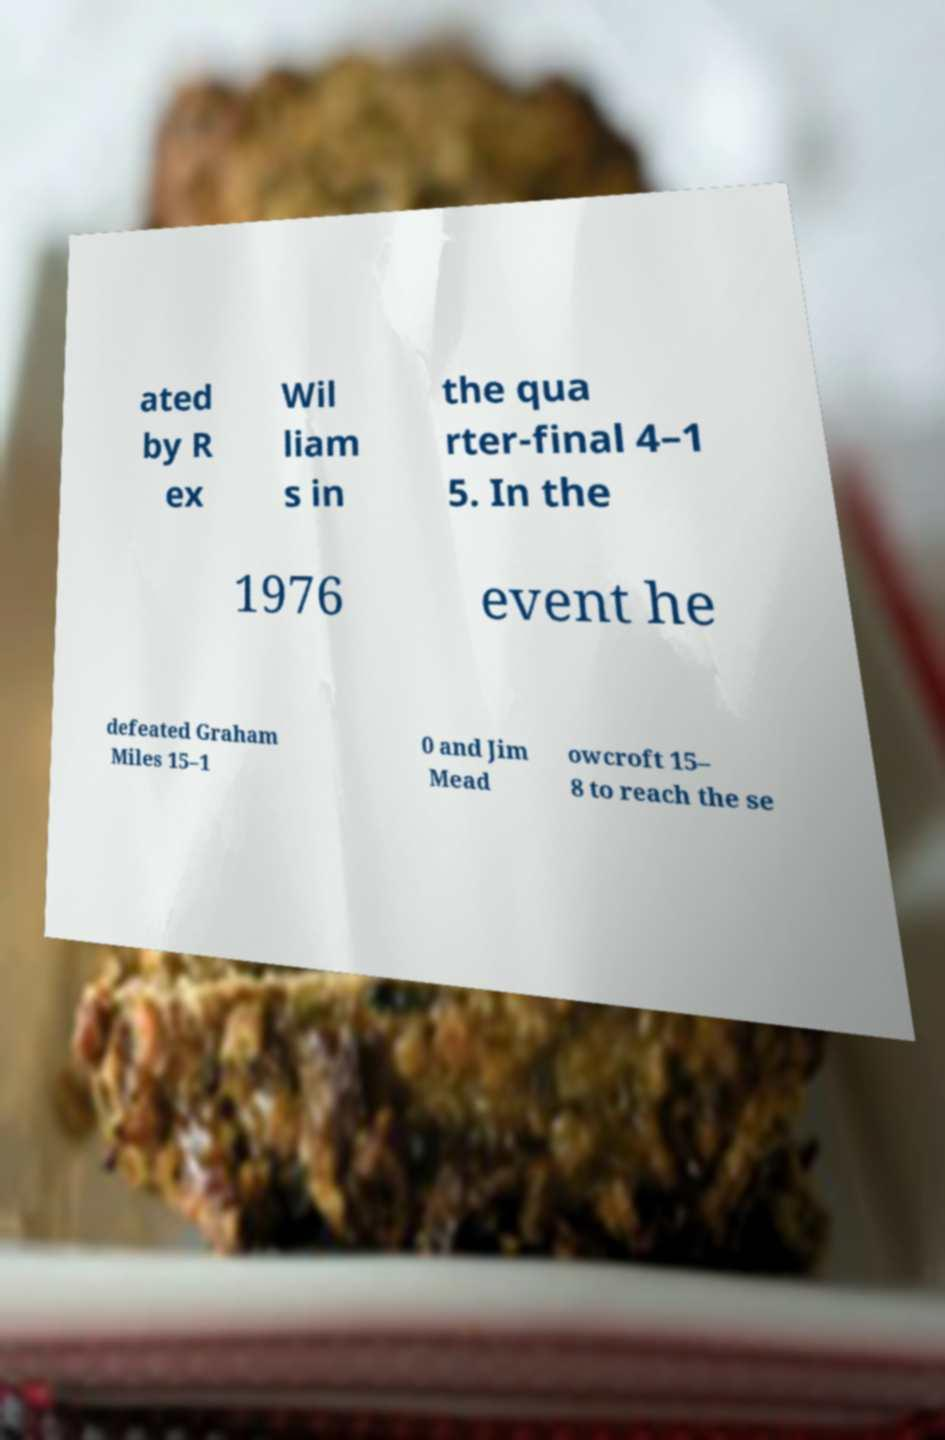For documentation purposes, I need the text within this image transcribed. Could you provide that? ated by R ex Wil liam s in the qua rter-final 4–1 5. In the 1976 event he defeated Graham Miles 15–1 0 and Jim Mead owcroft 15– 8 to reach the se 